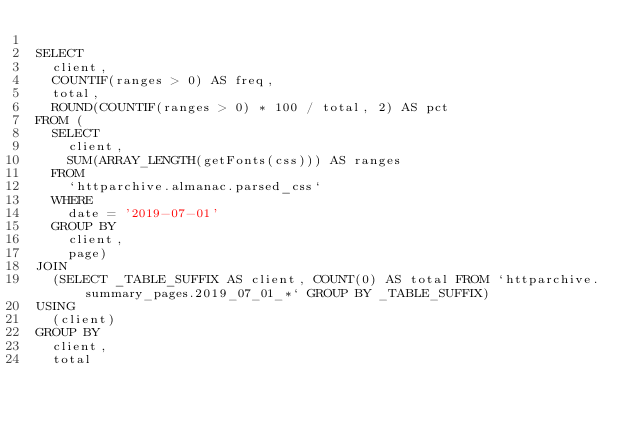Convert code to text. <code><loc_0><loc_0><loc_500><loc_500><_SQL_>
SELECT
  client,
  COUNTIF(ranges > 0) AS freq,
  total,
  ROUND(COUNTIF(ranges > 0) * 100 / total, 2) AS pct
FROM (
  SELECT
    client,
    SUM(ARRAY_LENGTH(getFonts(css))) AS ranges
  FROM
    `httparchive.almanac.parsed_css`
  WHERE
    date = '2019-07-01'
  GROUP BY
    client,
    page)
JOIN
  (SELECT _TABLE_SUFFIX AS client, COUNT(0) AS total FROM `httparchive.summary_pages.2019_07_01_*` GROUP BY _TABLE_SUFFIX)
USING
  (client)
GROUP BY
  client,
  total
</code> 